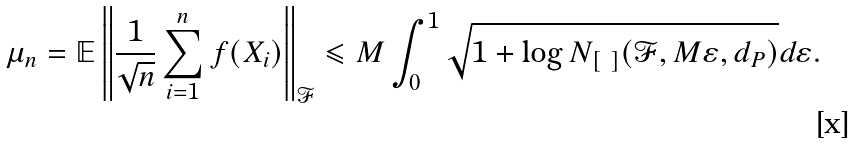Convert formula to latex. <formula><loc_0><loc_0><loc_500><loc_500>\mathbb { \mu } _ { n } = \mathbb { E } \left \| \frac { 1 } { \sqrt { n } } \sum _ { i = 1 } ^ { n } f ( X _ { i } ) \right \| _ { \mathcal { F } } \leqslant M \int _ { 0 } ^ { 1 } \sqrt { 1 + \log N _ { \left [ \ \right ] } ( \mathcal { F } , M \varepsilon , d _ { P } ) } d \varepsilon .</formula> 